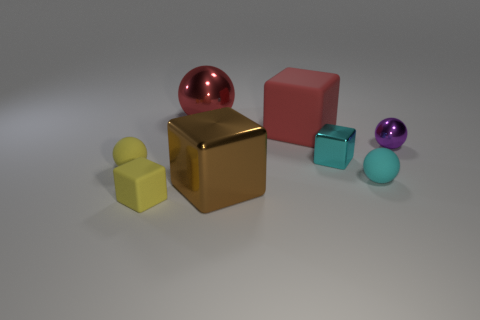Does the small rubber block have the same color as the tiny metallic block?
Provide a short and direct response. No. What number of cyan metallic objects are to the left of the tiny metal object that is in front of the tiny thing that is right of the tiny cyan matte sphere?
Your answer should be very brief. 0. What shape is the small yellow matte object right of the yellow object that is left of the small rubber block?
Provide a succinct answer. Cube. What is the size of the red object that is the same shape as the large brown thing?
Give a very brief answer. Large. Are there any other things that are the same size as the brown thing?
Keep it short and to the point. Yes. The ball on the left side of the large red metal object is what color?
Your response must be concise. Yellow. What is the small block behind the big cube in front of the matte cube on the right side of the big brown metallic cube made of?
Your answer should be compact. Metal. What size is the metallic ball that is left of the small cyan sphere that is to the right of the big sphere?
Your answer should be very brief. Large. What is the color of the small metal object that is the same shape as the big matte object?
Offer a very short reply. Cyan. How many matte objects are the same color as the tiny rubber cube?
Offer a terse response. 1. 